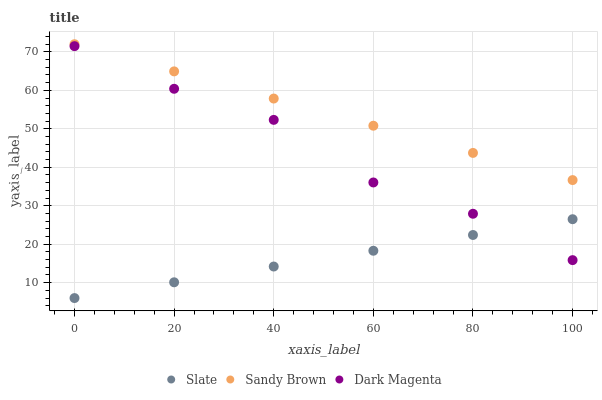Does Slate have the minimum area under the curve?
Answer yes or no. Yes. Does Sandy Brown have the maximum area under the curve?
Answer yes or no. Yes. Does Dark Magenta have the minimum area under the curve?
Answer yes or no. No. Does Dark Magenta have the maximum area under the curve?
Answer yes or no. No. Is Slate the smoothest?
Answer yes or no. Yes. Is Dark Magenta the roughest?
Answer yes or no. Yes. Is Sandy Brown the smoothest?
Answer yes or no. No. Is Sandy Brown the roughest?
Answer yes or no. No. Does Slate have the lowest value?
Answer yes or no. Yes. Does Dark Magenta have the lowest value?
Answer yes or no. No. Does Sandy Brown have the highest value?
Answer yes or no. Yes. Does Dark Magenta have the highest value?
Answer yes or no. No. Is Dark Magenta less than Sandy Brown?
Answer yes or no. Yes. Is Sandy Brown greater than Slate?
Answer yes or no. Yes. Does Dark Magenta intersect Slate?
Answer yes or no. Yes. Is Dark Magenta less than Slate?
Answer yes or no. No. Is Dark Magenta greater than Slate?
Answer yes or no. No. Does Dark Magenta intersect Sandy Brown?
Answer yes or no. No. 